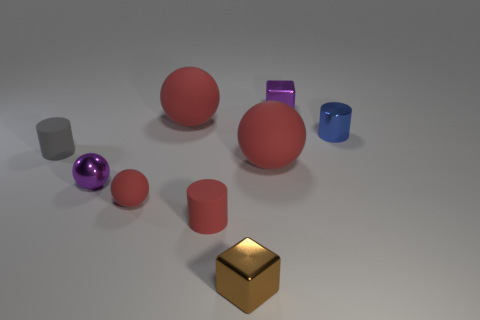Subtract all cyan cubes. How many red spheres are left? 3 Subtract all tiny purple metallic balls. How many balls are left? 3 Subtract all purple balls. How many balls are left? 3 Subtract all brown balls. Subtract all brown cylinders. How many balls are left? 4 Add 1 brown metal blocks. How many objects exist? 10 Subtract all blocks. How many objects are left? 7 Subtract 0 yellow cylinders. How many objects are left? 9 Subtract all small red shiny objects. Subtract all small purple metallic cubes. How many objects are left? 8 Add 4 gray things. How many gray things are left? 5 Add 4 tiny purple balls. How many tiny purple balls exist? 5 